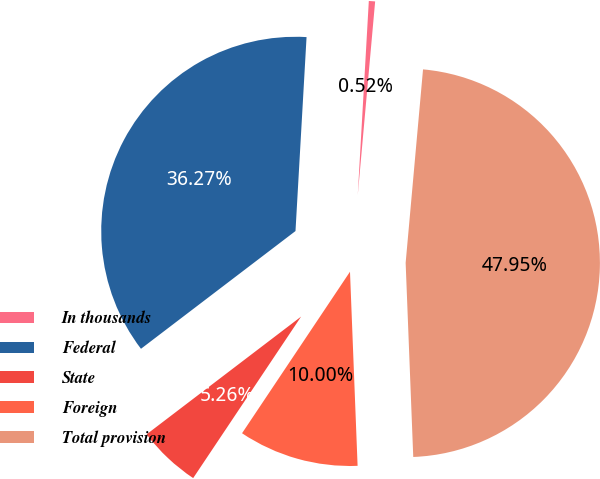<chart> <loc_0><loc_0><loc_500><loc_500><pie_chart><fcel>In thousands<fcel>Federal<fcel>State<fcel>Foreign<fcel>Total provision<nl><fcel>0.52%<fcel>36.27%<fcel>5.26%<fcel>10.0%<fcel>47.95%<nl></chart> 